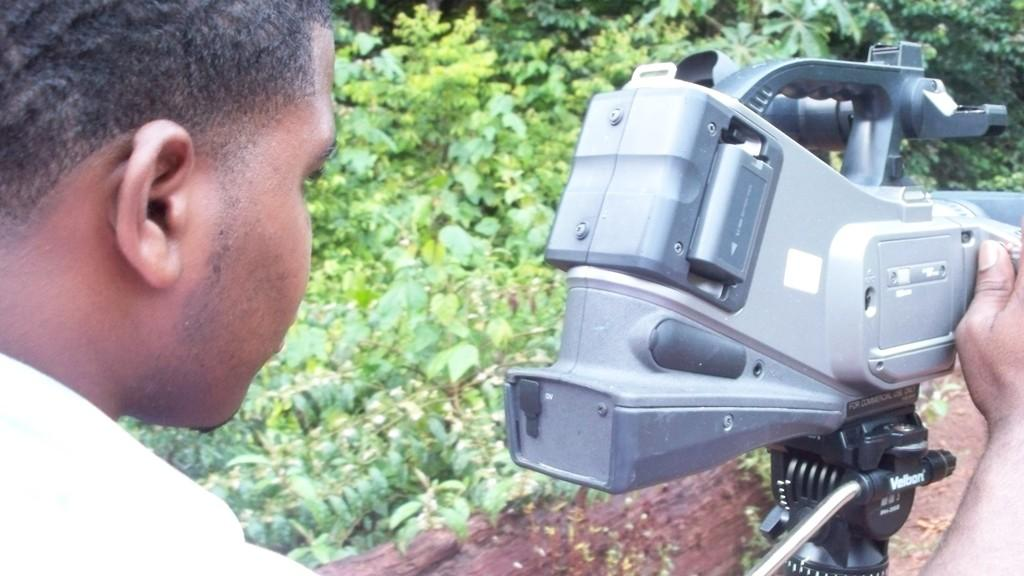Who is present in the image? There is a man in the image. What is the man holding in the image? The man is holding a machine in the image. What can be seen in the background of the image? There are many plants in the background of the image. How many planes can be seen flying in the image? There are no planes visible in the image. What type of goose is sitting on the man's shoulder in the image? There is no goose present in the image. 